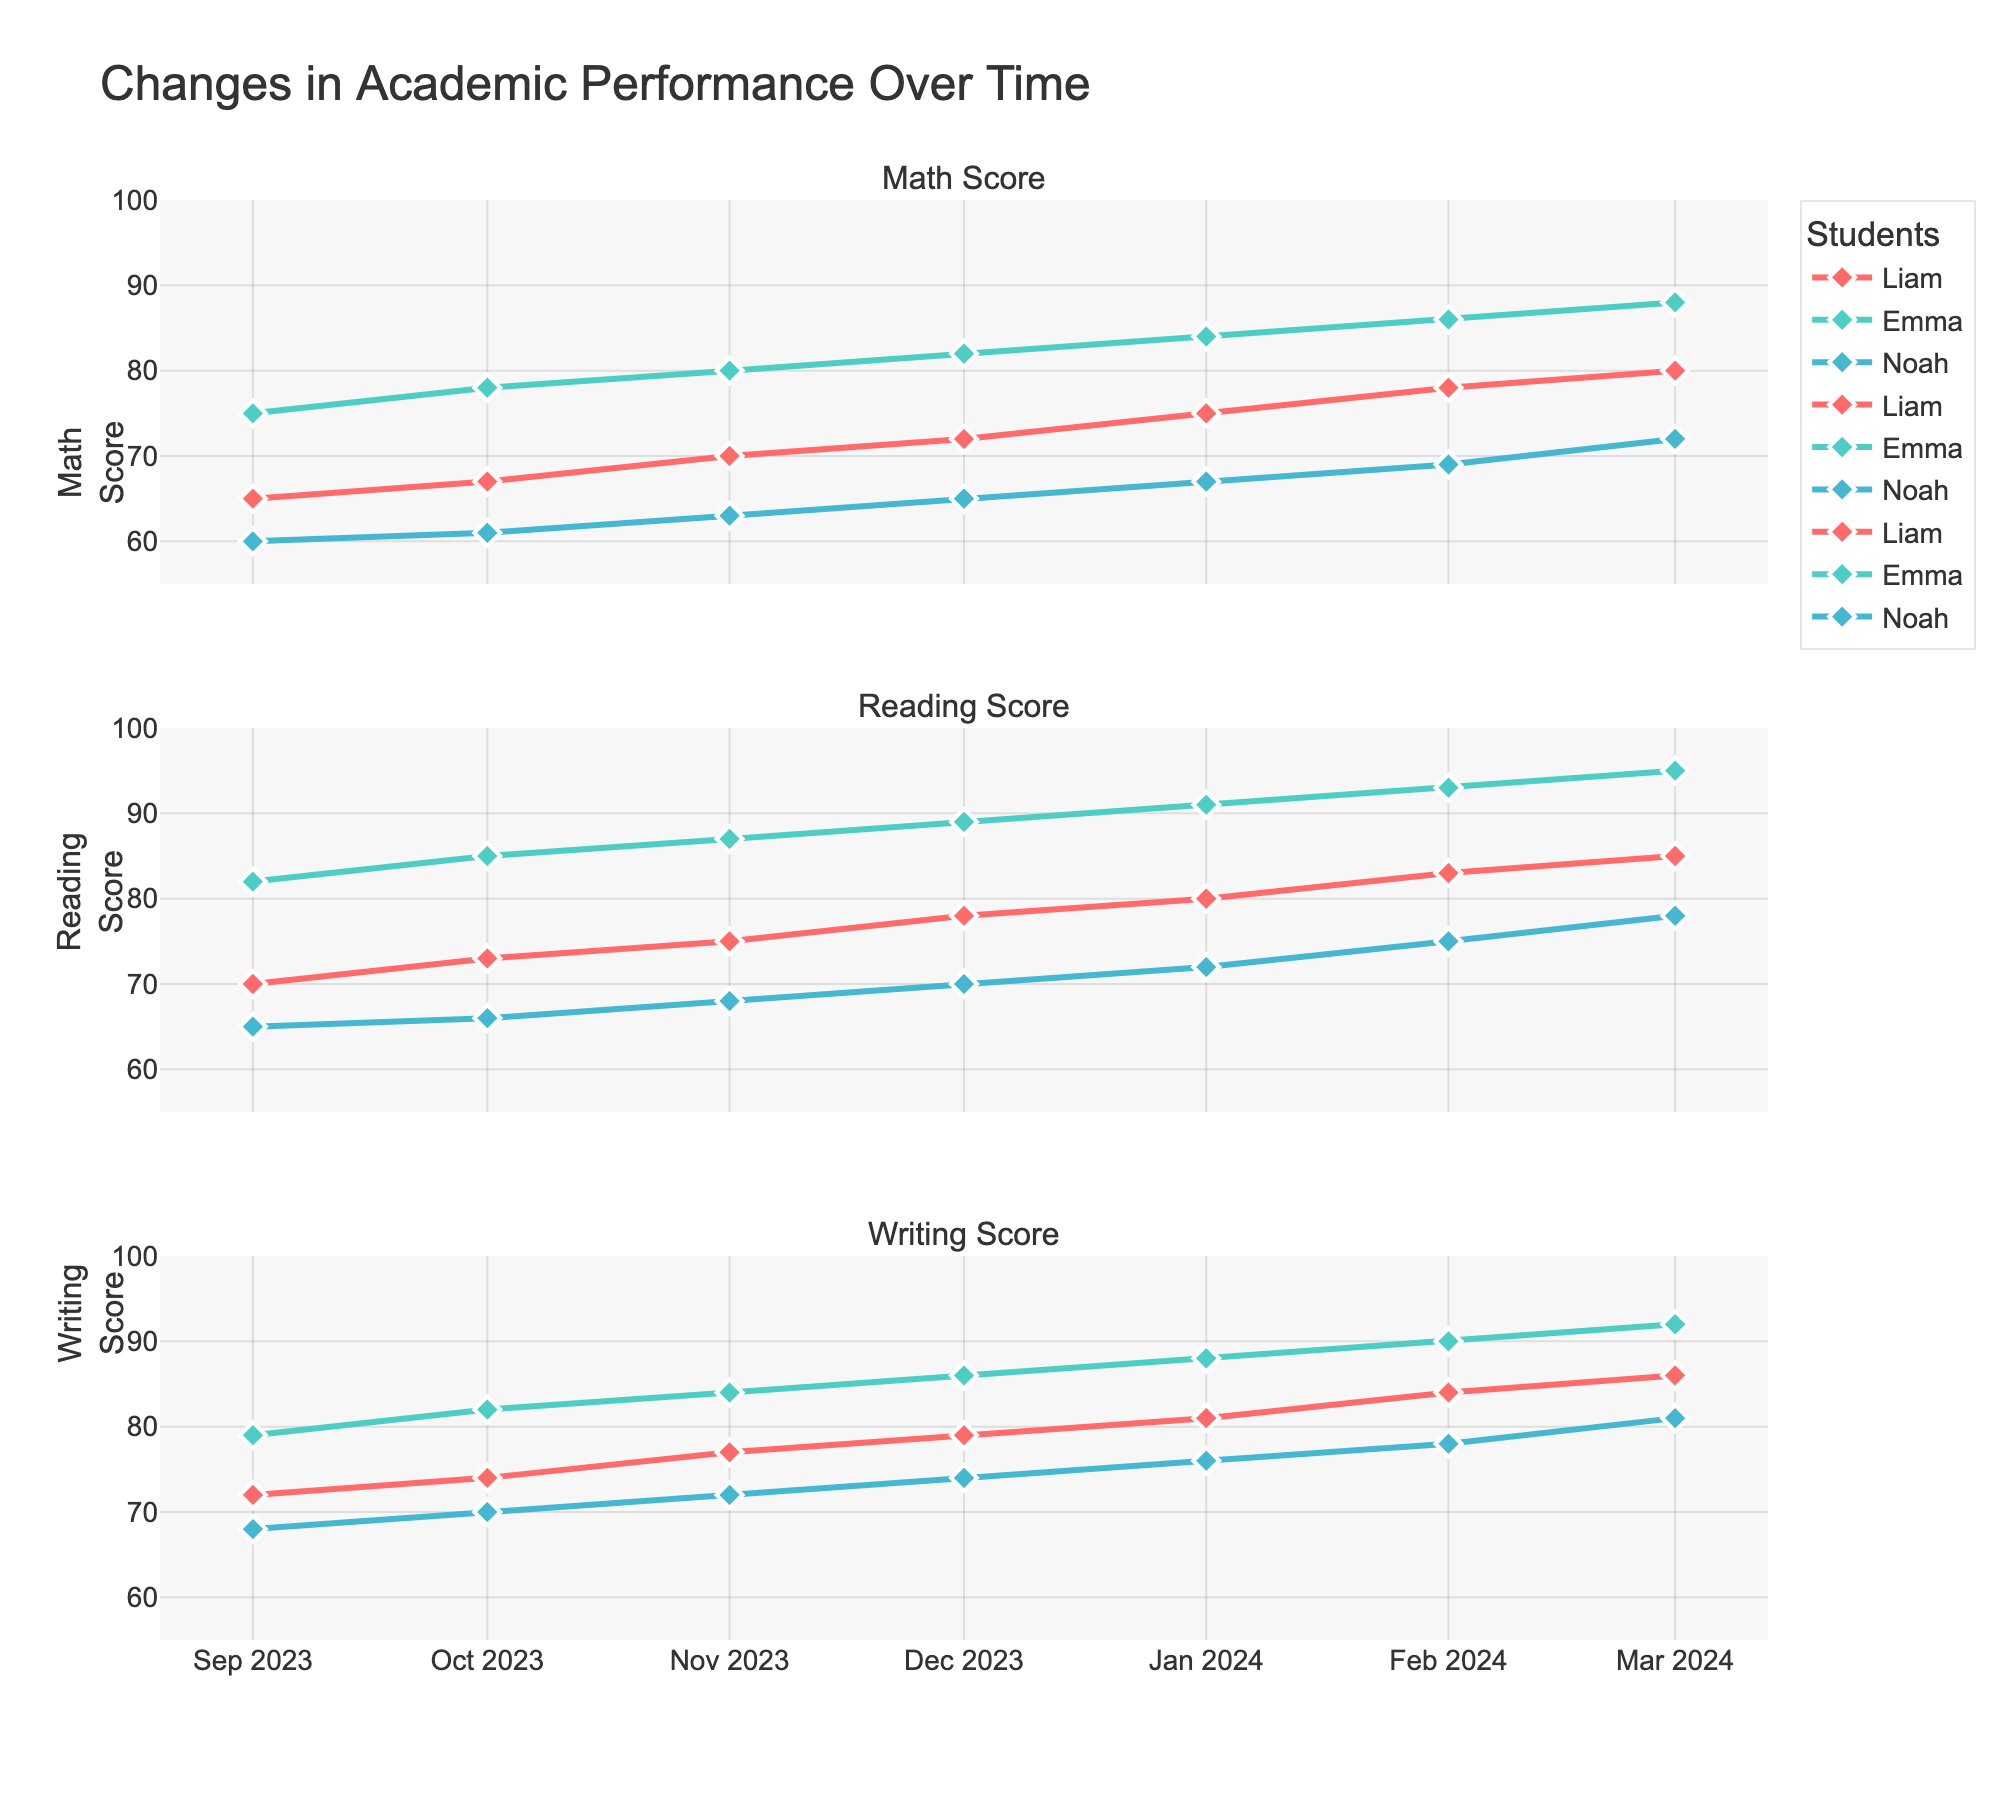What is the overall trend of the Math scores for Liam over the school year? The Math scores for Liam consistently increase month by month, starting from 65 in September 2023 and reaching 80 by March 2024.
Answer: Increasing Which student had the highest Writing score in January 2024? In January 2024, Emma had the highest Writing score, which was 88.
Answer: Emma How does Noah's Behavior Rating change between September 2023 and March 2024? Noah's Behavior Rating increased from 2 in September 2023 to 3 by February 2024 and remained at 3 in March 2024.
Answer: Increased Compare the Math scores of Liam and Noah in February 2024. Who scored higher? In February 2024, Liam scored 78 in Math, while Noah scored 69. Liam scored higher.
Answer: Liam What is the average Reading score of Emma over the school year? Emma’s Reading scores are 82, 85, 87, 89, 91, 93, and 95 across 7 months.  The sum is 622. Dividing 622 by 7 gives an average of approximately 89.
Answer: 89 Was there any month where Noah's Writing score was exactly equal to 70? If so, which month? In both December 2023 and October 2023, Noah’s Writing score was exactly 70.
Answer: December 2023 and October 2023 Between September 2023 and March 2024, by how many points did Emma's Reading score increase? Emma's Reading score increased from 82 in September 2023 to 95 in March 2024. The increase is 95 - 82 = 13.
Answer: 13 During which month did Liam's Math score surpass 70 for the first time? Liam's Math score surpassed 70 for the first time in November 2023, where he scored 70.
Answer: November 2023 Compare the trend of Behavior Ratings for Liam and Emma. Who had a stable Behavior Rating over the school year? Liam had a stable Behavior Rating of 3 throughout the year, while Emma's Behavior Rating remained constant at 4. Both had stable Behavior Ratings, but Emma’s rating was higher.
Answer: Both Considering all students, which subject scored the highest in March 2024? In March 2024, Emma's Reading score was 95, which was the highest among all subjects for that month.
Answer: Reading 